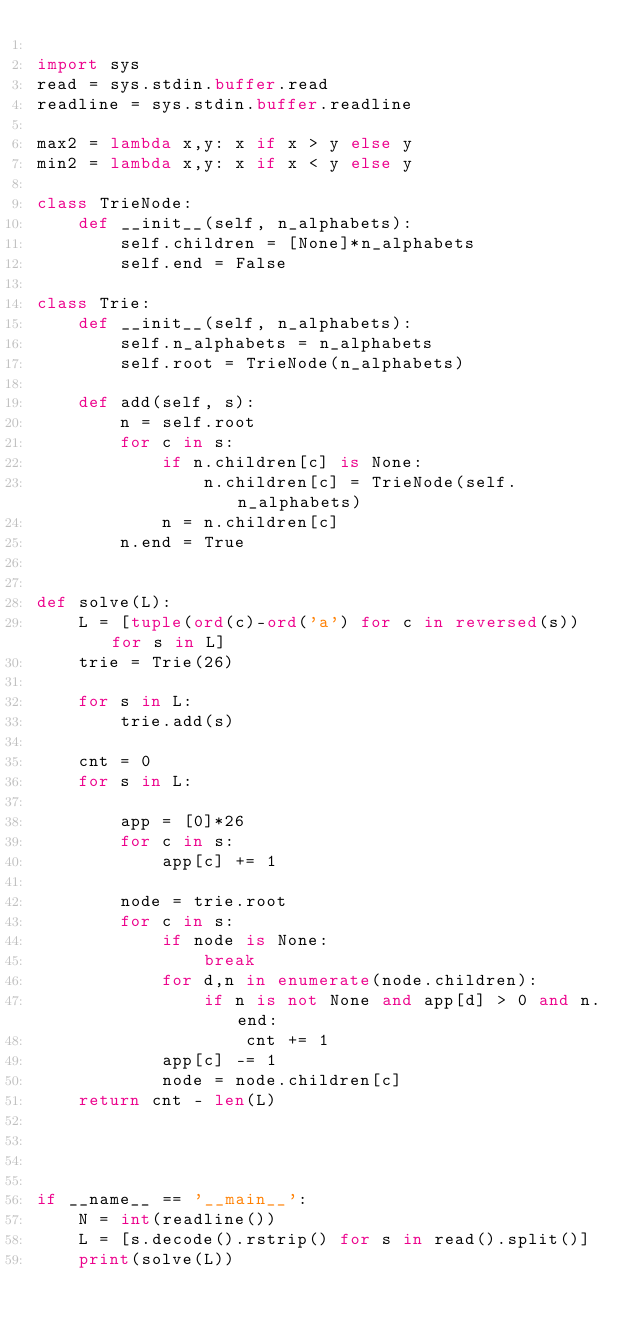<code> <loc_0><loc_0><loc_500><loc_500><_Python_>
import sys
read = sys.stdin.buffer.read
readline = sys.stdin.buffer.readline

max2 = lambda x,y: x if x > y else y
min2 = lambda x,y: x if x < y else y

class TrieNode:
    def __init__(self, n_alphabets):
        self.children = [None]*n_alphabets
        self.end = False

class Trie:
    def __init__(self, n_alphabets):
        self.n_alphabets = n_alphabets
        self.root = TrieNode(n_alphabets)

    def add(self, s):
        n = self.root
        for c in s:
            if n.children[c] is None:
                n.children[c] = TrieNode(self.n_alphabets)
            n = n.children[c]
        n.end = True


def solve(L):
    L = [tuple(ord(c)-ord('a') for c in reversed(s)) for s in L]
    trie = Trie(26)

    for s in L:
        trie.add(s)
    
    cnt = 0
    for s in L:

        app = [0]*26
        for c in s:
            app[c] += 1

        node = trie.root
        for c in s:
            if node is None:
                break
            for d,n in enumerate(node.children):
                if n is not None and app[d] > 0 and n.end:
                    cnt += 1
            app[c] -= 1
            node = node.children[c]
    return cnt - len(L)




if __name__ == '__main__':
    N = int(readline())
    L = [s.decode().rstrip() for s in read().split()]
    print(solve(L))</code> 